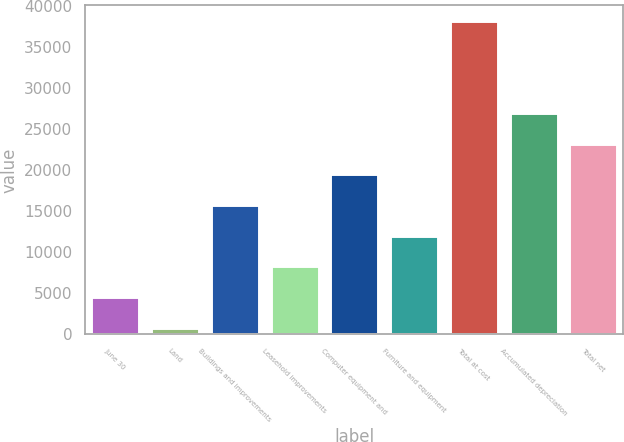Convert chart to OTSL. <chart><loc_0><loc_0><loc_500><loc_500><bar_chart><fcel>June 30<fcel>Land<fcel>Buildings and improvements<fcel>Leasehold improvements<fcel>Computer equipment and<fcel>Furniture and equipment<fcel>Total at cost<fcel>Accumulated depreciation<fcel>Total net<nl><fcel>4557.2<fcel>824<fcel>15756.8<fcel>8290.4<fcel>19490<fcel>12023.6<fcel>38156<fcel>26956.4<fcel>23223.2<nl></chart> 